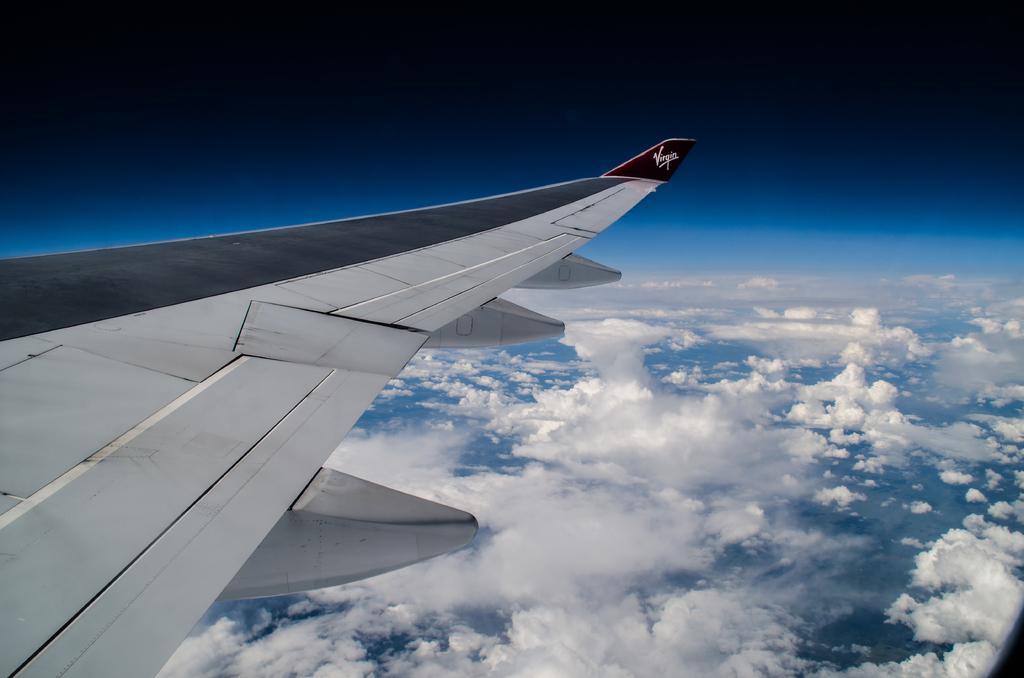In one or two sentences, can you explain what this image depicts? In this picture I can see an aircraft wing on the left side, on the right side there is the sky. 